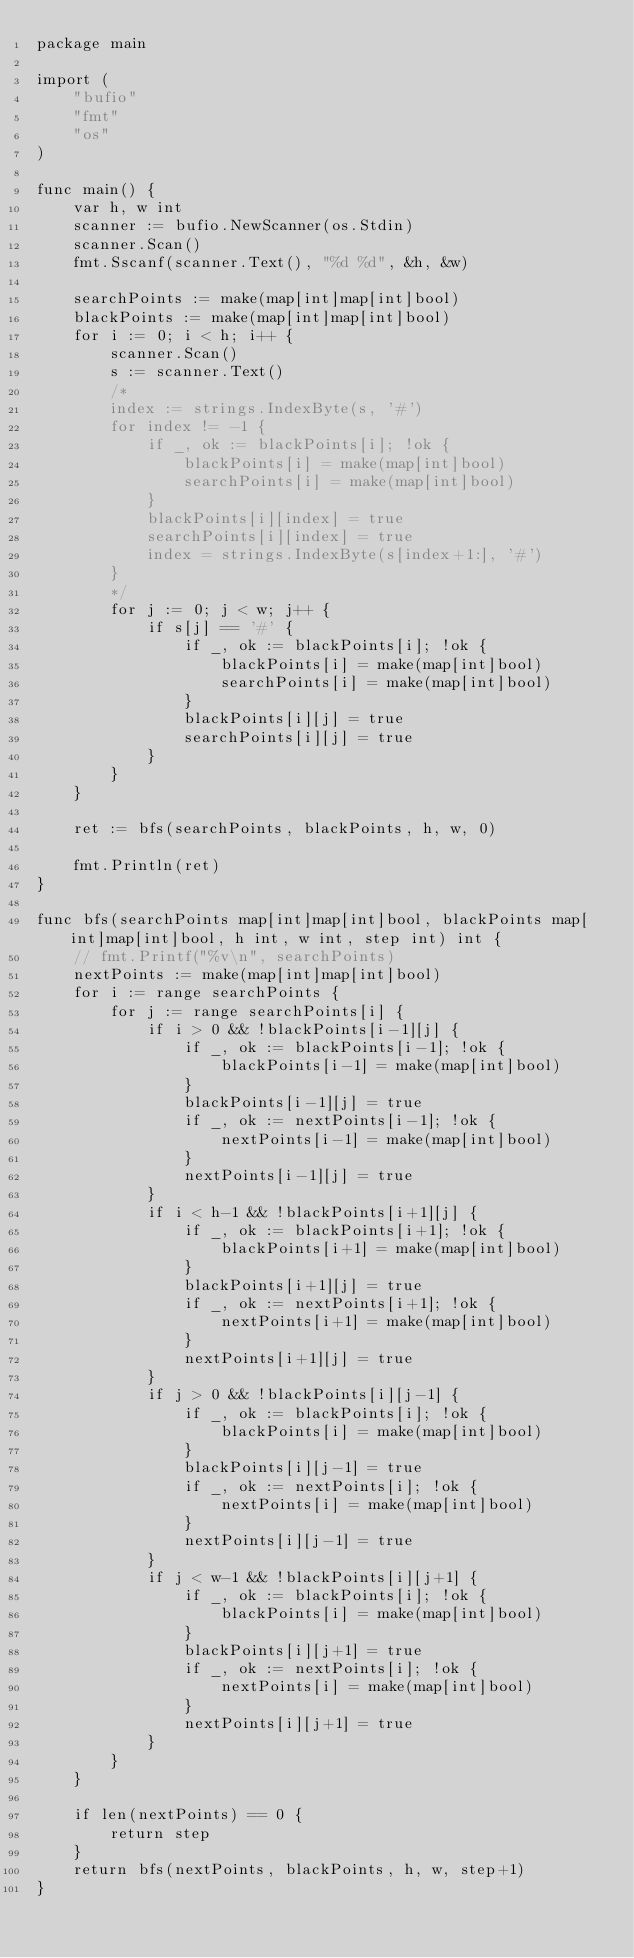Convert code to text. <code><loc_0><loc_0><loc_500><loc_500><_Go_>package main

import (
	"bufio"
	"fmt"
	"os"
)

func main() {
	var h, w int
	scanner := bufio.NewScanner(os.Stdin)
	scanner.Scan()
	fmt.Sscanf(scanner.Text(), "%d %d", &h, &w)

	searchPoints := make(map[int]map[int]bool)
	blackPoints := make(map[int]map[int]bool)
	for i := 0; i < h; i++ {
		scanner.Scan()
		s := scanner.Text()
		/*
		index := strings.IndexByte(s, '#')
		for index != -1 {
			if _, ok := blackPoints[i]; !ok {
				blackPoints[i] = make(map[int]bool)
				searchPoints[i] = make(map[int]bool)
			}
			blackPoints[i][index] = true
			searchPoints[i][index] = true
			index = strings.IndexByte(s[index+1:], '#')
		}
		*/
		for j := 0; j < w; j++ {
			if s[j] == '#' {
				if _, ok := blackPoints[i]; !ok {
					blackPoints[i] = make(map[int]bool)
					searchPoints[i] = make(map[int]bool)
				}
				blackPoints[i][j] = true
				searchPoints[i][j] = true
			}
		}
	}

	ret := bfs(searchPoints, blackPoints, h, w, 0)

	fmt.Println(ret)
}

func bfs(searchPoints map[int]map[int]bool, blackPoints map[int]map[int]bool, h int, w int, step int) int {
	// fmt.Printf("%v\n", searchPoints)
	nextPoints := make(map[int]map[int]bool)
	for i := range searchPoints {
		for j := range searchPoints[i] {
			if i > 0 && !blackPoints[i-1][j] {
				if _, ok := blackPoints[i-1]; !ok {
					blackPoints[i-1] = make(map[int]bool)
				}
				blackPoints[i-1][j] = true
				if _, ok := nextPoints[i-1]; !ok {
					nextPoints[i-1] = make(map[int]bool)
				}
				nextPoints[i-1][j] = true
			}
			if i < h-1 && !blackPoints[i+1][j] {
				if _, ok := blackPoints[i+1]; !ok {
					blackPoints[i+1] = make(map[int]bool)
				}
				blackPoints[i+1][j] = true
				if _, ok := nextPoints[i+1]; !ok {
					nextPoints[i+1] = make(map[int]bool)
				}
				nextPoints[i+1][j] = true
			}
			if j > 0 && !blackPoints[i][j-1] {
				if _, ok := blackPoints[i]; !ok {
					blackPoints[i] = make(map[int]bool)
				}
				blackPoints[i][j-1] = true
				if _, ok := nextPoints[i]; !ok {
					nextPoints[i] = make(map[int]bool)
				}
				nextPoints[i][j-1] = true
			}
			if j < w-1 && !blackPoints[i][j+1] {
				if _, ok := blackPoints[i]; !ok {
					blackPoints[i] = make(map[int]bool)
				}
				blackPoints[i][j+1] = true
				if _, ok := nextPoints[i]; !ok {
					nextPoints[i] = make(map[int]bool)
				}
				nextPoints[i][j+1] = true
			}
		}
	}

	if len(nextPoints) == 0 {
		return step
	}
	return bfs(nextPoints, blackPoints, h, w, step+1)
}
</code> 